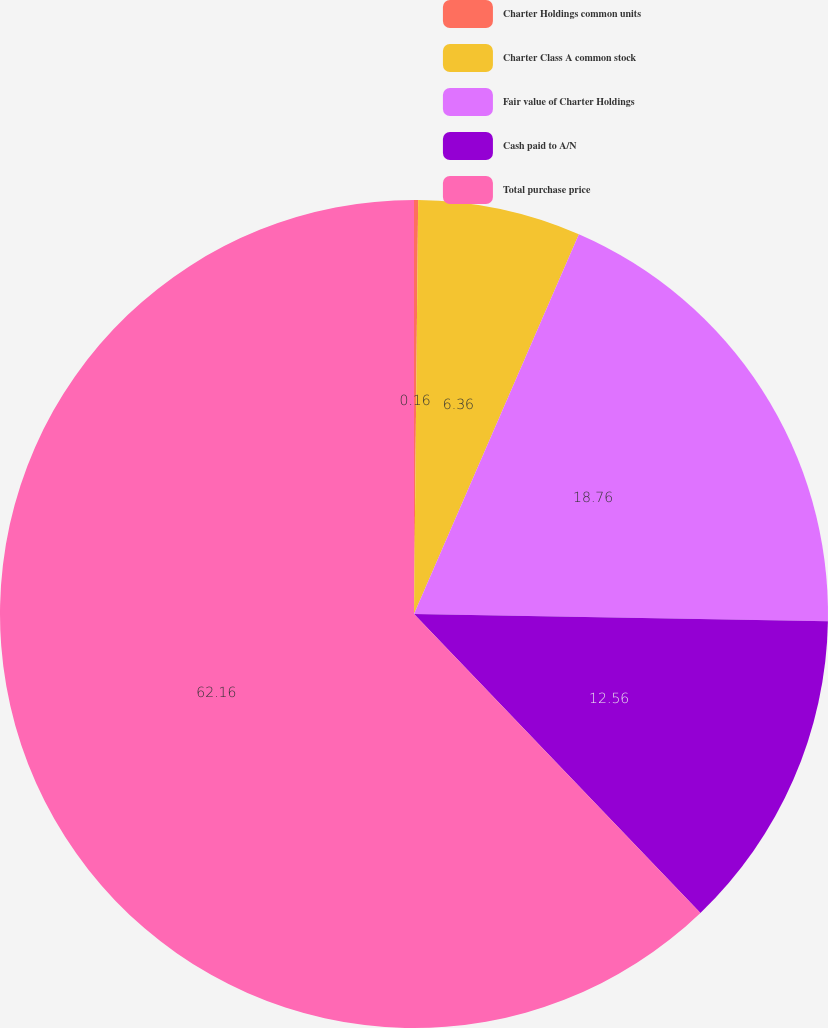<chart> <loc_0><loc_0><loc_500><loc_500><pie_chart><fcel>Charter Holdings common units<fcel>Charter Class A common stock<fcel>Fair value of Charter Holdings<fcel>Cash paid to A/N<fcel>Total purchase price<nl><fcel>0.16%<fcel>6.36%<fcel>18.76%<fcel>12.56%<fcel>62.16%<nl></chart> 